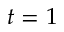<formula> <loc_0><loc_0><loc_500><loc_500>t = 1</formula> 